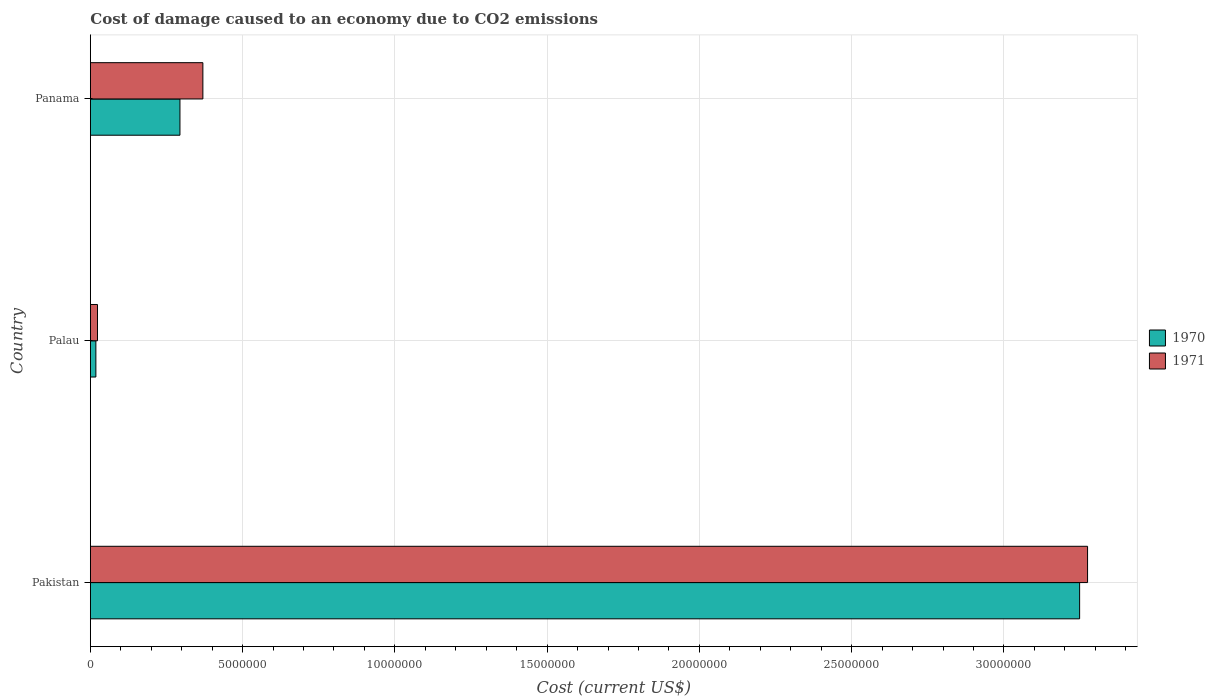How many different coloured bars are there?
Give a very brief answer. 2. How many groups of bars are there?
Your response must be concise. 3. How many bars are there on the 3rd tick from the top?
Provide a short and direct response. 2. How many bars are there on the 1st tick from the bottom?
Provide a short and direct response. 2. What is the label of the 2nd group of bars from the top?
Offer a very short reply. Palau. In how many cases, is the number of bars for a given country not equal to the number of legend labels?
Make the answer very short. 0. What is the cost of damage caused due to CO2 emissisons in 1971 in Pakistan?
Offer a very short reply. 3.27e+07. Across all countries, what is the maximum cost of damage caused due to CO2 emissisons in 1970?
Ensure brevity in your answer.  3.25e+07. Across all countries, what is the minimum cost of damage caused due to CO2 emissisons in 1971?
Provide a short and direct response. 2.34e+05. In which country was the cost of damage caused due to CO2 emissisons in 1970 minimum?
Offer a very short reply. Palau. What is the total cost of damage caused due to CO2 emissisons in 1970 in the graph?
Ensure brevity in your answer.  3.56e+07. What is the difference between the cost of damage caused due to CO2 emissisons in 1970 in Pakistan and that in Panama?
Offer a very short reply. 2.95e+07. What is the difference between the cost of damage caused due to CO2 emissisons in 1971 in Palau and the cost of damage caused due to CO2 emissisons in 1970 in Pakistan?
Provide a succinct answer. -3.23e+07. What is the average cost of damage caused due to CO2 emissisons in 1970 per country?
Provide a succinct answer. 1.19e+07. What is the difference between the cost of damage caused due to CO2 emissisons in 1970 and cost of damage caused due to CO2 emissisons in 1971 in Pakistan?
Your answer should be compact. -2.61e+05. In how many countries, is the cost of damage caused due to CO2 emissisons in 1971 greater than 16000000 US$?
Give a very brief answer. 1. What is the ratio of the cost of damage caused due to CO2 emissisons in 1971 in Pakistan to that in Palau?
Keep it short and to the point. 139.84. Is the cost of damage caused due to CO2 emissisons in 1970 in Pakistan less than that in Panama?
Your response must be concise. No. Is the difference between the cost of damage caused due to CO2 emissisons in 1970 in Pakistan and Panama greater than the difference between the cost of damage caused due to CO2 emissisons in 1971 in Pakistan and Panama?
Offer a very short reply. Yes. What is the difference between the highest and the second highest cost of damage caused due to CO2 emissisons in 1971?
Offer a terse response. 2.91e+07. What is the difference between the highest and the lowest cost of damage caused due to CO2 emissisons in 1971?
Your response must be concise. 3.25e+07. Is the sum of the cost of damage caused due to CO2 emissisons in 1971 in Pakistan and Panama greater than the maximum cost of damage caused due to CO2 emissisons in 1970 across all countries?
Your answer should be compact. Yes. What does the 1st bar from the top in Panama represents?
Your answer should be very brief. 1971. How many bars are there?
Your answer should be compact. 6. Are all the bars in the graph horizontal?
Make the answer very short. Yes. How many countries are there in the graph?
Ensure brevity in your answer.  3. Does the graph contain grids?
Offer a terse response. Yes. Where does the legend appear in the graph?
Provide a short and direct response. Center right. How many legend labels are there?
Provide a short and direct response. 2. What is the title of the graph?
Provide a short and direct response. Cost of damage caused to an economy due to CO2 emissions. Does "2008" appear as one of the legend labels in the graph?
Your response must be concise. No. What is the label or title of the X-axis?
Provide a short and direct response. Cost (current US$). What is the Cost (current US$) of 1970 in Pakistan?
Provide a succinct answer. 3.25e+07. What is the Cost (current US$) in 1971 in Pakistan?
Provide a short and direct response. 3.27e+07. What is the Cost (current US$) in 1970 in Palau?
Keep it short and to the point. 1.81e+05. What is the Cost (current US$) in 1971 in Palau?
Give a very brief answer. 2.34e+05. What is the Cost (current US$) in 1970 in Panama?
Offer a terse response. 2.94e+06. What is the Cost (current US$) in 1971 in Panama?
Your answer should be very brief. 3.69e+06. Across all countries, what is the maximum Cost (current US$) of 1970?
Offer a very short reply. 3.25e+07. Across all countries, what is the maximum Cost (current US$) in 1971?
Make the answer very short. 3.27e+07. Across all countries, what is the minimum Cost (current US$) in 1970?
Make the answer very short. 1.81e+05. Across all countries, what is the minimum Cost (current US$) of 1971?
Offer a very short reply. 2.34e+05. What is the total Cost (current US$) of 1970 in the graph?
Offer a terse response. 3.56e+07. What is the total Cost (current US$) in 1971 in the graph?
Give a very brief answer. 3.67e+07. What is the difference between the Cost (current US$) in 1970 in Pakistan and that in Palau?
Give a very brief answer. 3.23e+07. What is the difference between the Cost (current US$) in 1971 in Pakistan and that in Palau?
Provide a succinct answer. 3.25e+07. What is the difference between the Cost (current US$) of 1970 in Pakistan and that in Panama?
Provide a succinct answer. 2.95e+07. What is the difference between the Cost (current US$) of 1971 in Pakistan and that in Panama?
Provide a succinct answer. 2.91e+07. What is the difference between the Cost (current US$) in 1970 in Palau and that in Panama?
Offer a very short reply. -2.76e+06. What is the difference between the Cost (current US$) in 1971 in Palau and that in Panama?
Offer a very short reply. -3.46e+06. What is the difference between the Cost (current US$) of 1970 in Pakistan and the Cost (current US$) of 1971 in Palau?
Keep it short and to the point. 3.23e+07. What is the difference between the Cost (current US$) of 1970 in Pakistan and the Cost (current US$) of 1971 in Panama?
Your answer should be compact. 2.88e+07. What is the difference between the Cost (current US$) of 1970 in Palau and the Cost (current US$) of 1971 in Panama?
Keep it short and to the point. -3.51e+06. What is the average Cost (current US$) of 1970 per country?
Your answer should be compact. 1.19e+07. What is the average Cost (current US$) of 1971 per country?
Offer a terse response. 1.22e+07. What is the difference between the Cost (current US$) of 1970 and Cost (current US$) of 1971 in Pakistan?
Your response must be concise. -2.61e+05. What is the difference between the Cost (current US$) in 1970 and Cost (current US$) in 1971 in Palau?
Your response must be concise. -5.31e+04. What is the difference between the Cost (current US$) in 1970 and Cost (current US$) in 1971 in Panama?
Make the answer very short. -7.53e+05. What is the ratio of the Cost (current US$) in 1970 in Pakistan to that in Palau?
Your answer should be very brief. 179.38. What is the ratio of the Cost (current US$) in 1971 in Pakistan to that in Palau?
Make the answer very short. 139.84. What is the ratio of the Cost (current US$) of 1970 in Pakistan to that in Panama?
Offer a very short reply. 11.04. What is the ratio of the Cost (current US$) in 1971 in Pakistan to that in Panama?
Provide a short and direct response. 8.86. What is the ratio of the Cost (current US$) in 1970 in Palau to that in Panama?
Offer a very short reply. 0.06. What is the ratio of the Cost (current US$) in 1971 in Palau to that in Panama?
Make the answer very short. 0.06. What is the difference between the highest and the second highest Cost (current US$) of 1970?
Make the answer very short. 2.95e+07. What is the difference between the highest and the second highest Cost (current US$) of 1971?
Provide a succinct answer. 2.91e+07. What is the difference between the highest and the lowest Cost (current US$) of 1970?
Provide a short and direct response. 3.23e+07. What is the difference between the highest and the lowest Cost (current US$) of 1971?
Provide a short and direct response. 3.25e+07. 